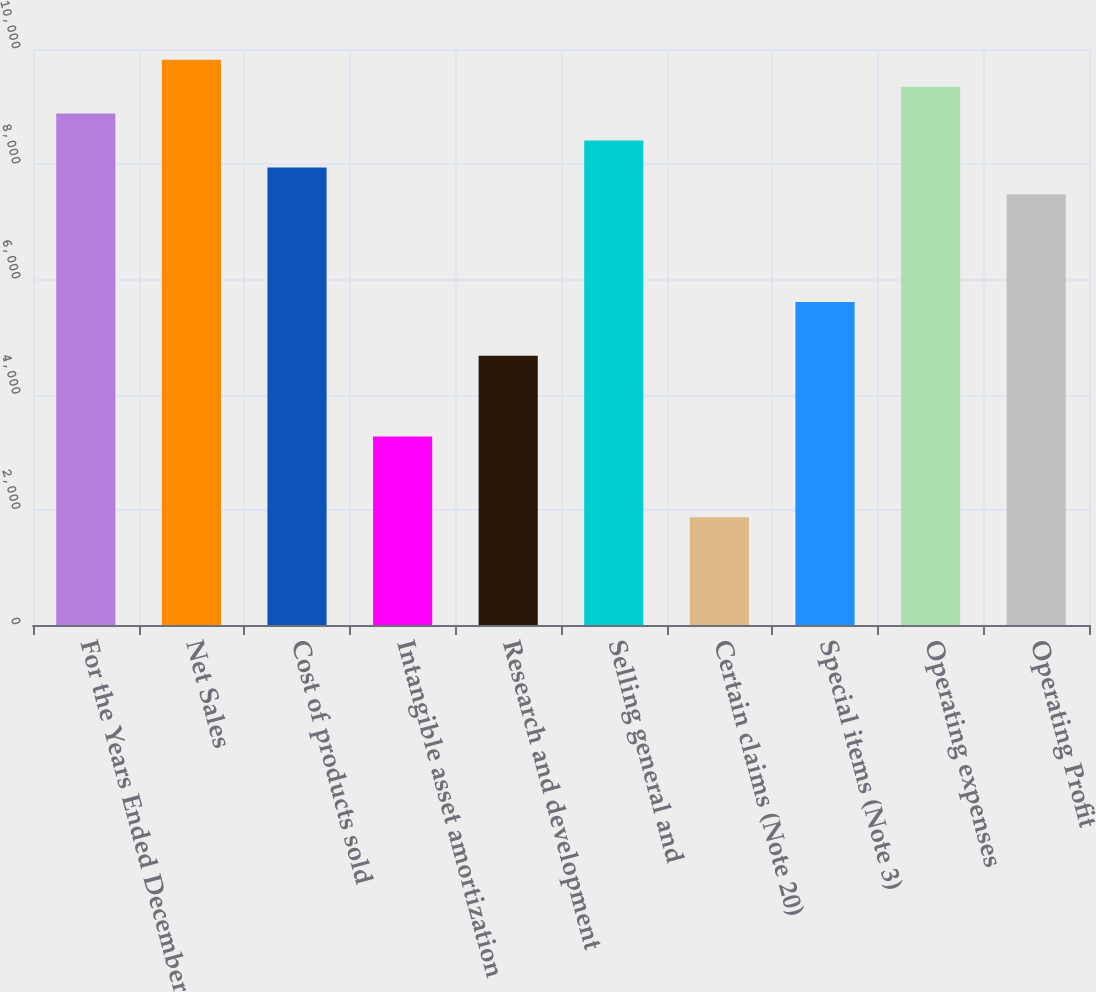Convert chart to OTSL. <chart><loc_0><loc_0><loc_500><loc_500><bar_chart><fcel>For the Years Ended December<fcel>Net Sales<fcel>Cost of products sold<fcel>Intangible asset amortization<fcel>Research and development<fcel>Selling general and<fcel>Certain claims (Note 20)<fcel>Special items (Note 3)<fcel>Operating expenses<fcel>Operating Profit<nl><fcel>8878.44<fcel>9812.92<fcel>7943.96<fcel>3271.56<fcel>4673.28<fcel>8411.2<fcel>1869.84<fcel>5607.76<fcel>9345.68<fcel>7476.72<nl></chart> 